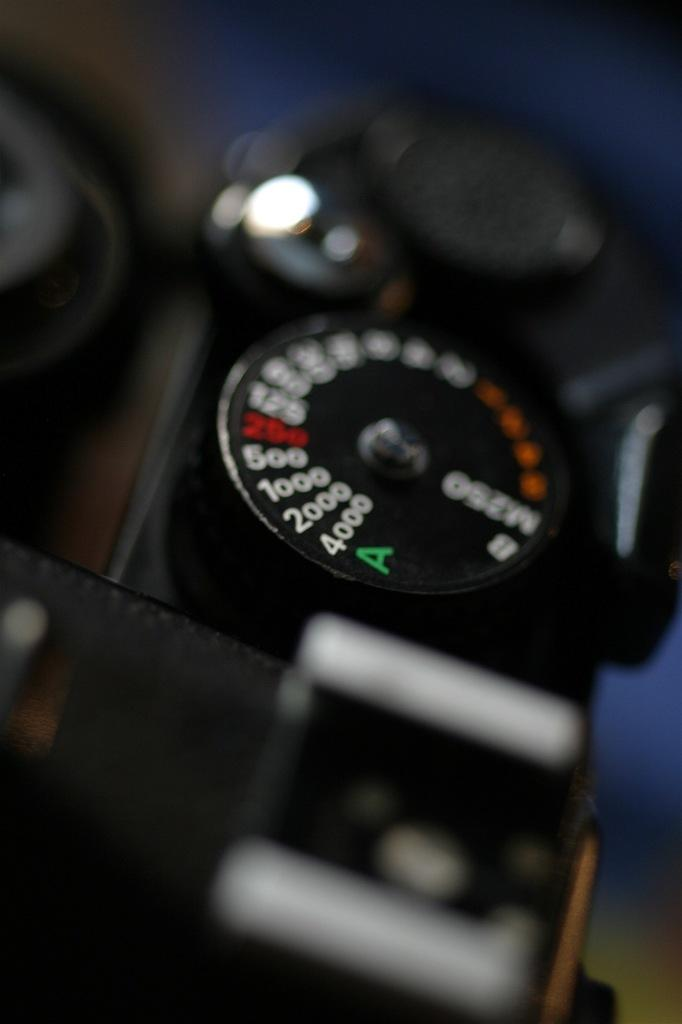What is the color of the object in the image? The object in the image is black. What is on the black object? The black object has words written on it. What colors are used for the words on the black object? The words have white, red, orange, and green colors. How would you describe the background of the image? The background of the image is blurry. What type of oil is being used for the bath in the image? There is no mention of a bath or oil in the image; it features a black object with words written on it. 